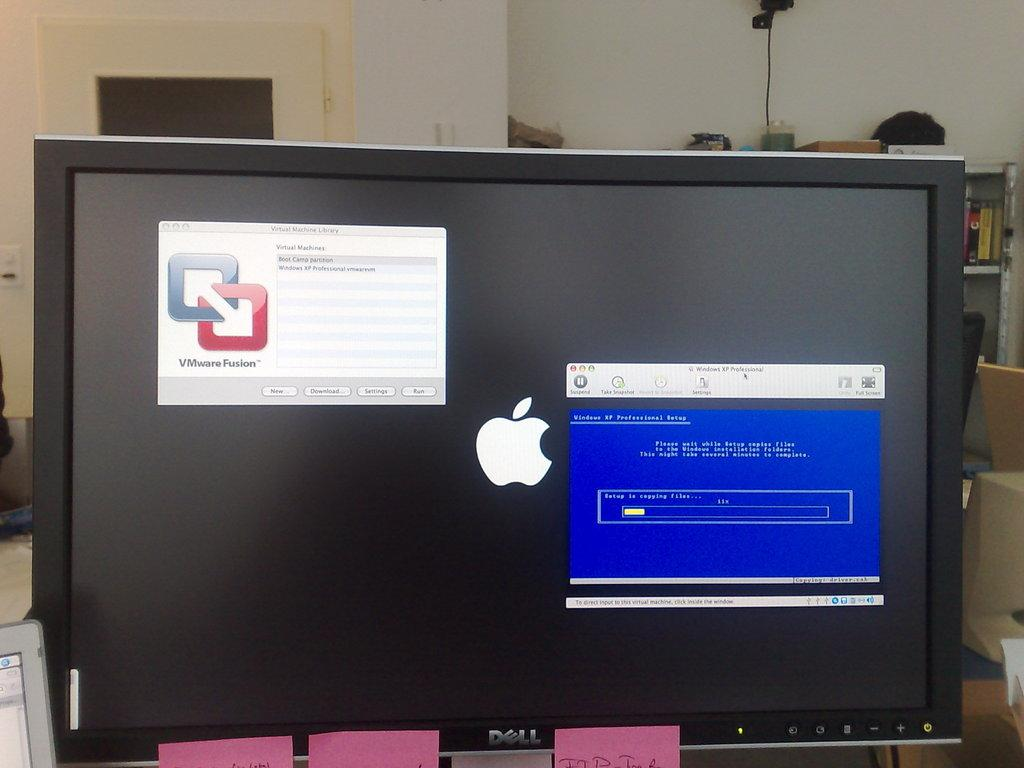<image>
Summarize the visual content of the image. An apple monitor has two squares with the words VMware Fusion in the upper left corner. 